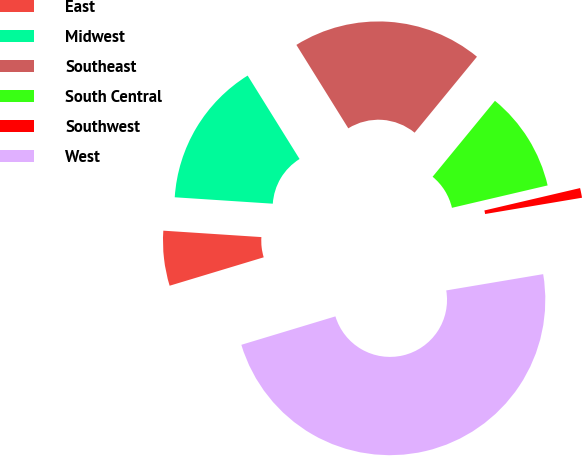Convert chart. <chart><loc_0><loc_0><loc_500><loc_500><pie_chart><fcel>East<fcel>Midwest<fcel>Southeast<fcel>South Central<fcel>Southwest<fcel>West<nl><fcel>5.71%<fcel>15.1%<fcel>19.8%<fcel>10.4%<fcel>1.01%<fcel>47.98%<nl></chart> 